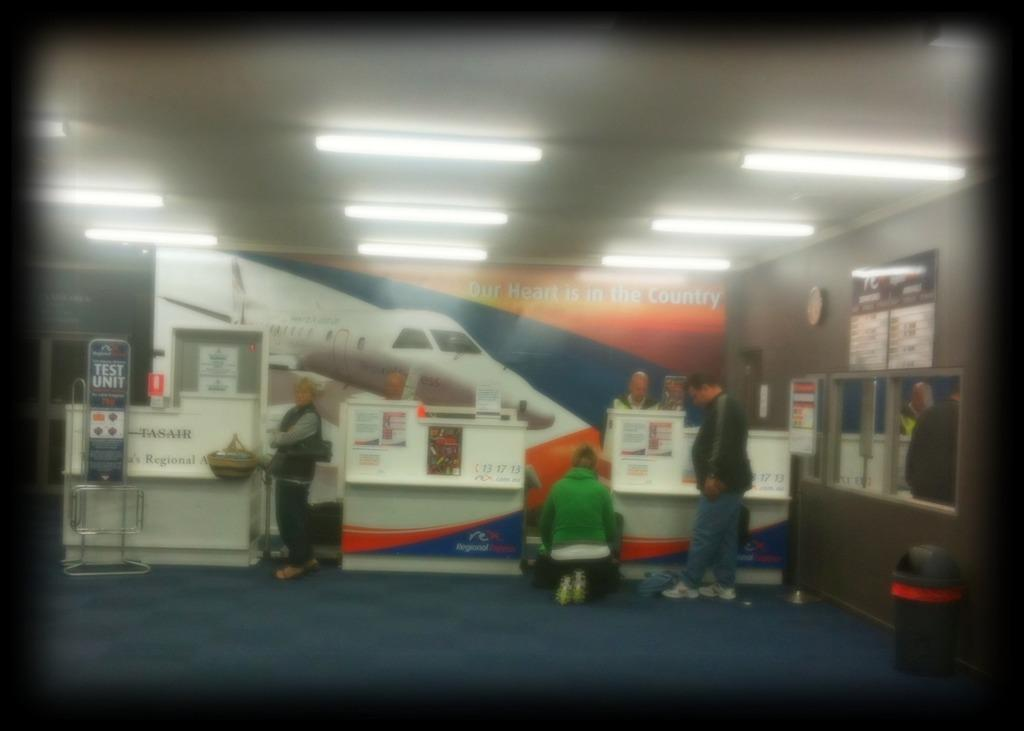How many people can be seen in the image? There are persons in the image, but the exact number is not specified. What type of furniture is present in the image? There are tables in the image. What type of decorations are visible in the image? There are posters and frames in the image. What type of container is present in the image? There is a bin in the image. What type of structure is present in the background of the image? There is a door in the background of the image. What type of surface is present in the background of the image? There is a wall in the background of the image. What type of illumination is present in the background of the image? There are lights in the background of the image. Can you see a crow perched on the door in the image? There is no crow present in the image. Is there any blood visible on the persons in the image? There is no mention of blood in the image, and it is not visible in the provided facts. 